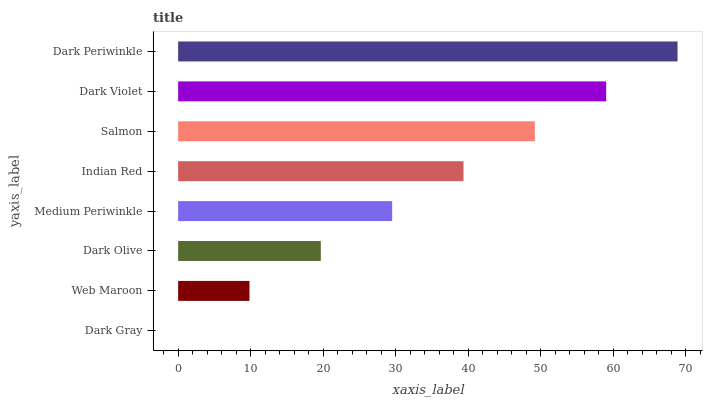Is Dark Gray the minimum?
Answer yes or no. Yes. Is Dark Periwinkle the maximum?
Answer yes or no. Yes. Is Web Maroon the minimum?
Answer yes or no. No. Is Web Maroon the maximum?
Answer yes or no. No. Is Web Maroon greater than Dark Gray?
Answer yes or no. Yes. Is Dark Gray less than Web Maroon?
Answer yes or no. Yes. Is Dark Gray greater than Web Maroon?
Answer yes or no. No. Is Web Maroon less than Dark Gray?
Answer yes or no. No. Is Indian Red the high median?
Answer yes or no. Yes. Is Medium Periwinkle the low median?
Answer yes or no. Yes. Is Salmon the high median?
Answer yes or no. No. Is Indian Red the low median?
Answer yes or no. No. 